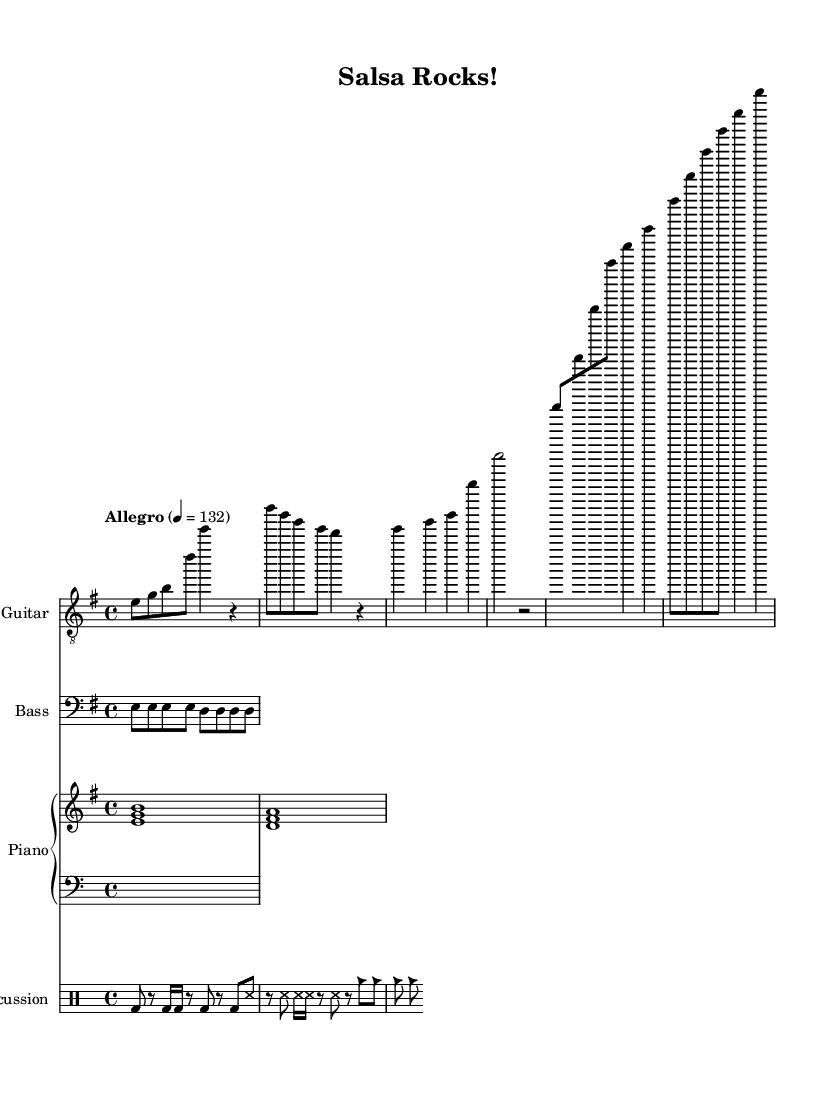What is the key signature of this music? The key signature is marked as E minor, which has one sharp (F#).
Answer: E minor What is the time signature of this music? The time signature is indicated as 4/4, which means there are four beats in each measure.
Answer: 4/4 What is the tempo marking for this piece? The tempo marking is given as Allegro, and the metronome marking indicates it should be played at 132 beats per minute.
Answer: Allegro How many measures are in the intro section? The intro consists of two measures, as identified by the two distinct parts of music written before the verse.
Answer: 2 What are the instruments featured in this composition? The composition includes four instruments: Electric Guitar, Bass, Piano, and Percussion.
Answer: Electric Guitar, Bass, Piano, Percussion Which section has a different pattern for the percussion? The conga, timbales, and cowbell patterns are distinct from each other, indicating the percussion section showcases variety. The different patterns are evident in measures assigned to each.
Answer: Percussion section What notes are played in the verse section for the electric guitar? In the verse section, the electric guitar plays the notes E, G, B, and D, followed by E for two beats.
Answer: E, G, B, D 